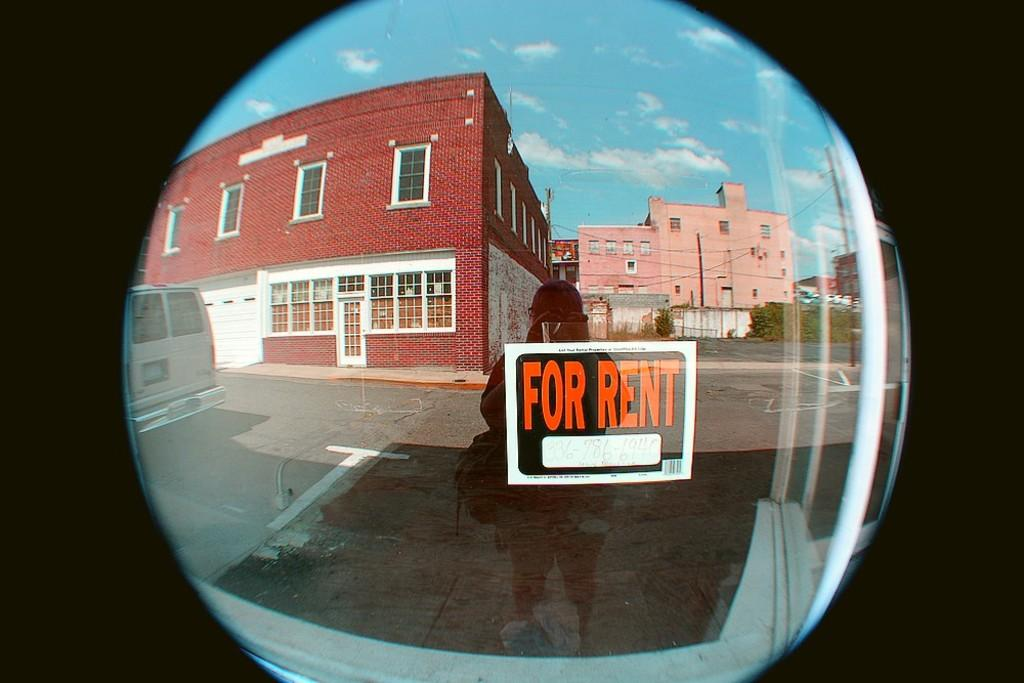<image>
Create a compact narrative representing the image presented. A window has a black sign that says For Rent in orange bold letters. 